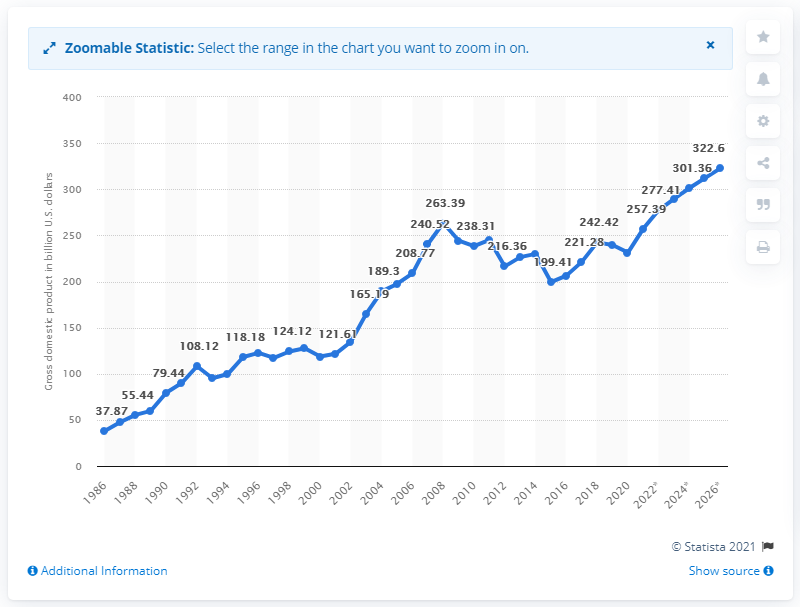Point out several critical features in this image. In 2020, the gross domestic product of Portugal was 231.35 billion dollars. 